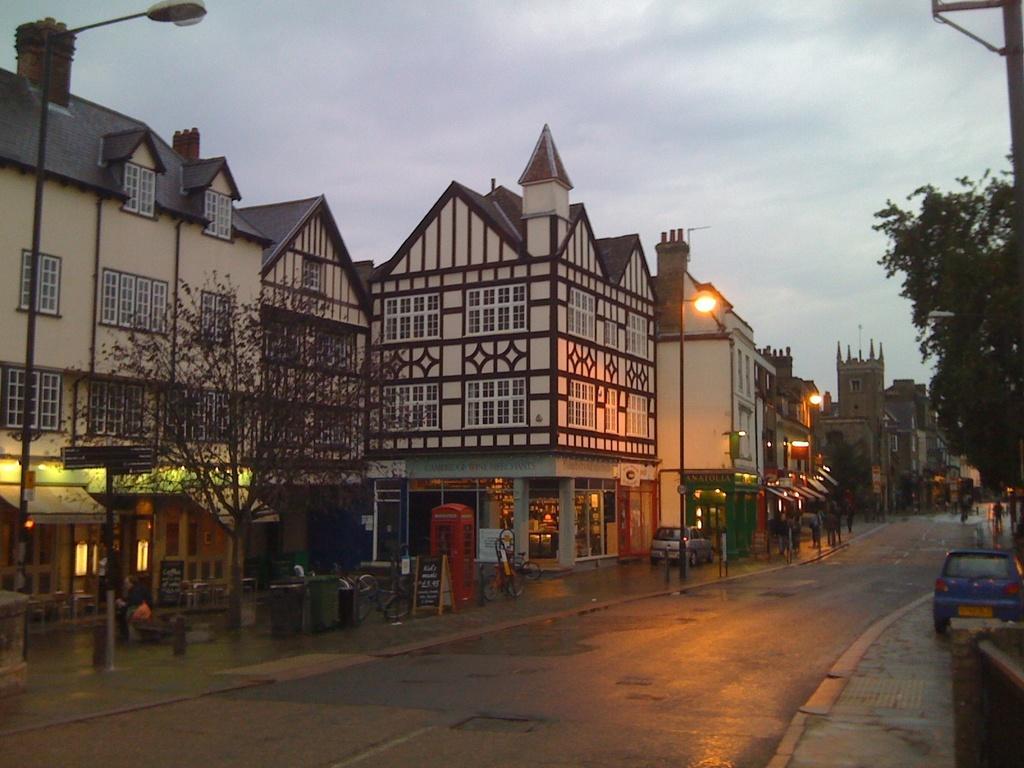Describe this image in one or two sentences. These are the buildings with windows. This looks like a dustbin. I can see few bicycles, which are parked. This looks like a telephone booth. I can see two cars, which are parked beside the road. These are the trees. This looks like a street light. In the background, I can see few people. 